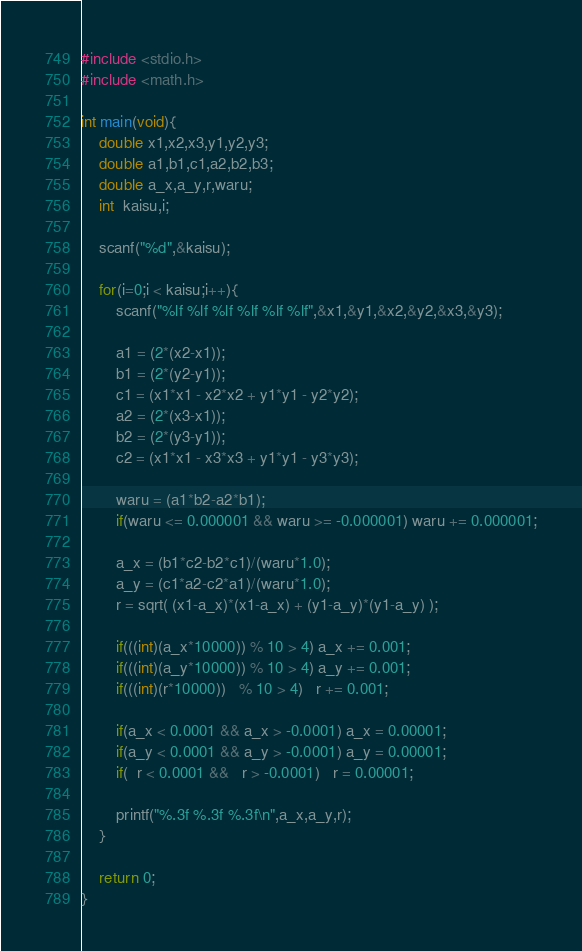<code> <loc_0><loc_0><loc_500><loc_500><_C_>#include <stdio.h>
#include <math.h>

int main(void){
	double x1,x2,x3,y1,y2,y3;
	double a1,b1,c1,a2,b2,b3;
	double a_x,a_y,r,waru;
	int  kaisu,i;
	
	scanf("%d",&kaisu);
	
	for(i=0;i < kaisu;i++){
		scanf("%lf %lf %lf %lf %lf %lf",&x1,&y1,&x2,&y2,&x3,&y3);
		
		a1 = (2*(x2-x1));
		b1 = (2*(y2-y1));
		c1 = (x1*x1 - x2*x2 + y1*y1 - y2*y2);
		a2 = (2*(x3-x1));
		b2 = (2*(y3-y1));
		c2 = (x1*x1 - x3*x3 + y1*y1 - y3*y3);
		
		waru = (a1*b2-a2*b1);
		if(waru <= 0.000001 && waru >= -0.000001) waru += 0.000001;
		
		a_x = (b1*c2-b2*c1)/(waru*1.0);
		a_y = (c1*a2-c2*a1)/(waru*1.0);
		r = sqrt( (x1-a_x)*(x1-a_x) + (y1-a_y)*(y1-a_y) );
		
		if(((int)(a_x*10000)) % 10 > 4) a_x += 0.001;
		if(((int)(a_y*10000)) % 10 > 4) a_y += 0.001;
		if(((int)(r*10000))   % 10 > 4)   r += 0.001;
		
		if(a_x < 0.0001 && a_x > -0.0001) a_x = 0.00001;
		if(a_y < 0.0001 && a_y > -0.0001) a_y = 0.00001;
		if(  r < 0.0001 &&   r > -0.0001)   r = 0.00001;
		
		printf("%.3f %.3f %.3f\n",a_x,a_y,r);
	}
	
	return 0;
}</code> 